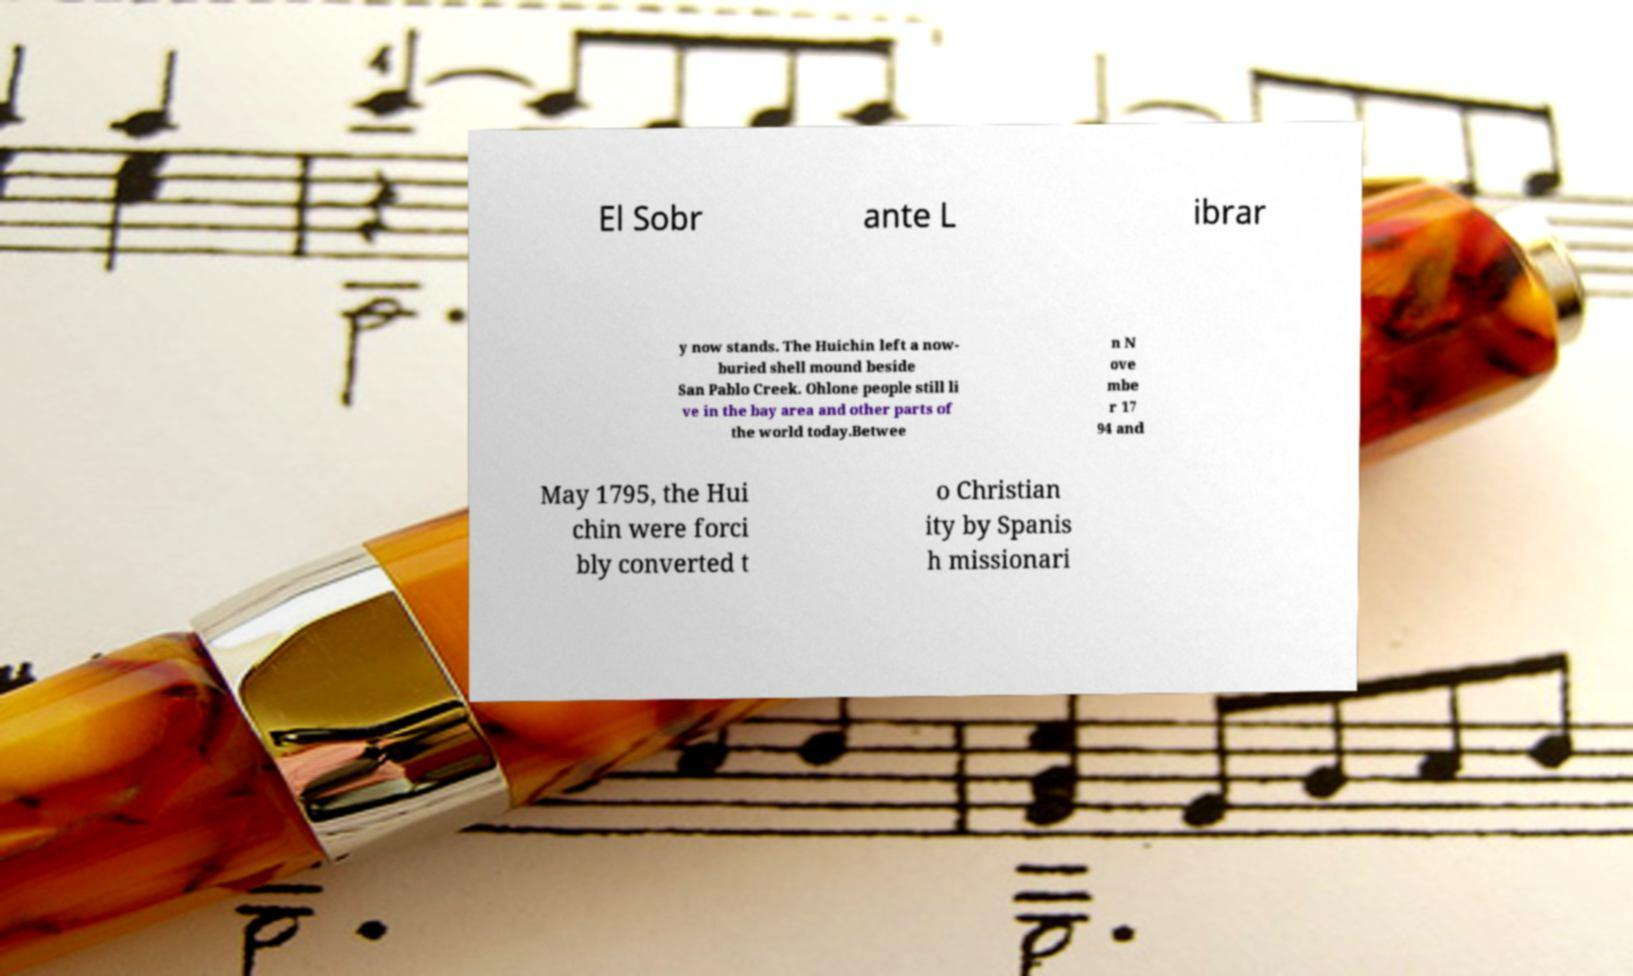Can you read and provide the text displayed in the image?This photo seems to have some interesting text. Can you extract and type it out for me? El Sobr ante L ibrar y now stands. The Huichin left a now- buried shell mound beside San Pablo Creek. Ohlone people still li ve in the bay area and other parts of the world today.Betwee n N ove mbe r 17 94 and May 1795, the Hui chin were forci bly converted t o Christian ity by Spanis h missionari 